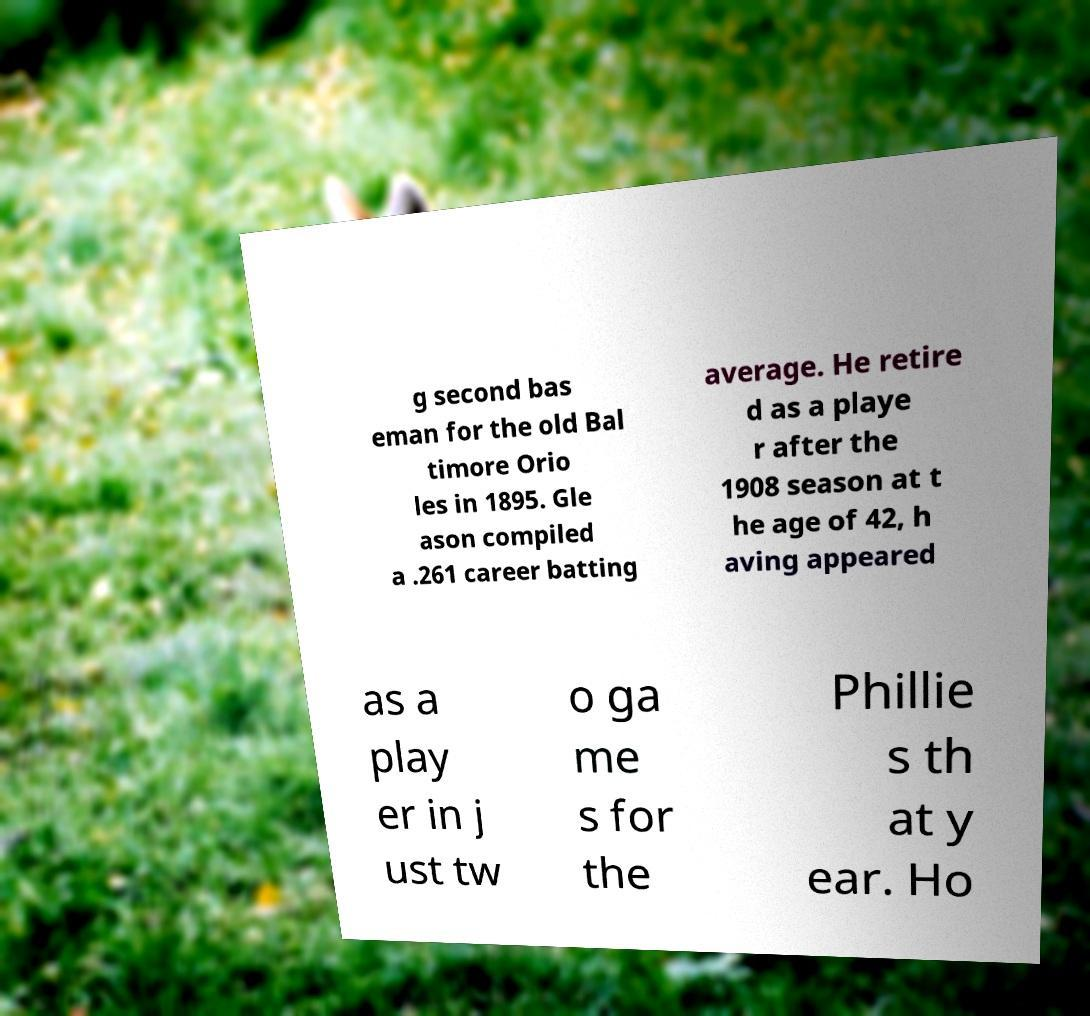What messages or text are displayed in this image? I need them in a readable, typed format. g second bas eman for the old Bal timore Orio les in 1895. Gle ason compiled a .261 career batting average. He retire d as a playe r after the 1908 season at t he age of 42, h aving appeared as a play er in j ust tw o ga me s for the Phillie s th at y ear. Ho 